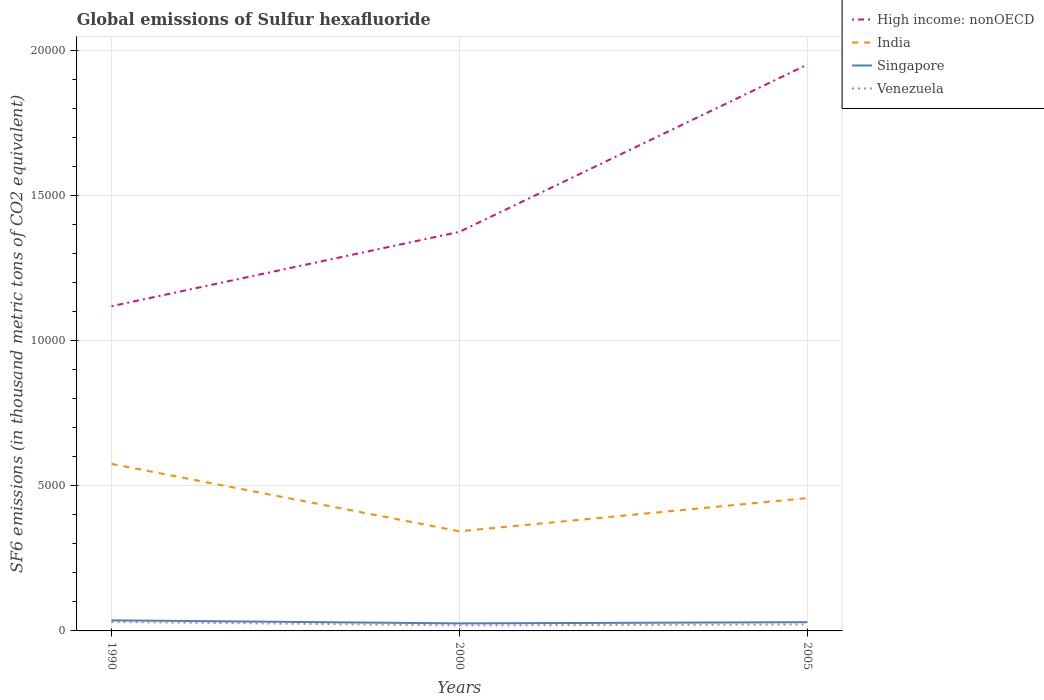How many different coloured lines are there?
Make the answer very short. 4. Does the line corresponding to Venezuela intersect with the line corresponding to High income: nonOECD?
Ensure brevity in your answer.  No. Is the number of lines equal to the number of legend labels?
Offer a very short reply. Yes. Across all years, what is the maximum global emissions of Sulfur hexafluoride in High income: nonOECD?
Keep it short and to the point. 1.12e+04. What is the total global emissions of Sulfur hexafluoride in Singapore in the graph?
Your answer should be very brief. -41.4. What is the difference between the highest and the second highest global emissions of Sulfur hexafluoride in Venezuela?
Offer a terse response. 118.4. How many lines are there?
Keep it short and to the point. 4. How many years are there in the graph?
Your answer should be compact. 3. What is the difference between two consecutive major ticks on the Y-axis?
Make the answer very short. 5000. Are the values on the major ticks of Y-axis written in scientific E-notation?
Ensure brevity in your answer.  No. Does the graph contain grids?
Your answer should be very brief. Yes. How many legend labels are there?
Offer a very short reply. 4. What is the title of the graph?
Keep it short and to the point. Global emissions of Sulfur hexafluoride. Does "Least developed countries" appear as one of the legend labels in the graph?
Your answer should be very brief. No. What is the label or title of the X-axis?
Your response must be concise. Years. What is the label or title of the Y-axis?
Keep it short and to the point. SF6 emissions (in thousand metric tons of CO2 equivalent). What is the SF6 emissions (in thousand metric tons of CO2 equivalent) of High income: nonOECD in 1990?
Ensure brevity in your answer.  1.12e+04. What is the SF6 emissions (in thousand metric tons of CO2 equivalent) of India in 1990?
Ensure brevity in your answer.  5757.5. What is the SF6 emissions (in thousand metric tons of CO2 equivalent) of Singapore in 1990?
Provide a short and direct response. 364.7. What is the SF6 emissions (in thousand metric tons of CO2 equivalent) of Venezuela in 1990?
Offer a terse response. 309.8. What is the SF6 emissions (in thousand metric tons of CO2 equivalent) of High income: nonOECD in 2000?
Make the answer very short. 1.38e+04. What is the SF6 emissions (in thousand metric tons of CO2 equivalent) of India in 2000?
Ensure brevity in your answer.  3434.7. What is the SF6 emissions (in thousand metric tons of CO2 equivalent) of Singapore in 2000?
Keep it short and to the point. 259.8. What is the SF6 emissions (in thousand metric tons of CO2 equivalent) in Venezuela in 2000?
Give a very brief answer. 191.4. What is the SF6 emissions (in thousand metric tons of CO2 equivalent) of High income: nonOECD in 2005?
Ensure brevity in your answer.  1.95e+04. What is the SF6 emissions (in thousand metric tons of CO2 equivalent) of India in 2005?
Your response must be concise. 4578.7. What is the SF6 emissions (in thousand metric tons of CO2 equivalent) in Singapore in 2005?
Your answer should be very brief. 301.2. What is the SF6 emissions (in thousand metric tons of CO2 equivalent) in Venezuela in 2005?
Offer a terse response. 225.1. Across all years, what is the maximum SF6 emissions (in thousand metric tons of CO2 equivalent) in High income: nonOECD?
Keep it short and to the point. 1.95e+04. Across all years, what is the maximum SF6 emissions (in thousand metric tons of CO2 equivalent) in India?
Offer a very short reply. 5757.5. Across all years, what is the maximum SF6 emissions (in thousand metric tons of CO2 equivalent) in Singapore?
Ensure brevity in your answer.  364.7. Across all years, what is the maximum SF6 emissions (in thousand metric tons of CO2 equivalent) in Venezuela?
Provide a succinct answer. 309.8. Across all years, what is the minimum SF6 emissions (in thousand metric tons of CO2 equivalent) in High income: nonOECD?
Offer a very short reply. 1.12e+04. Across all years, what is the minimum SF6 emissions (in thousand metric tons of CO2 equivalent) in India?
Keep it short and to the point. 3434.7. Across all years, what is the minimum SF6 emissions (in thousand metric tons of CO2 equivalent) in Singapore?
Provide a short and direct response. 259.8. Across all years, what is the minimum SF6 emissions (in thousand metric tons of CO2 equivalent) in Venezuela?
Your response must be concise. 191.4. What is the total SF6 emissions (in thousand metric tons of CO2 equivalent) in High income: nonOECD in the graph?
Ensure brevity in your answer.  4.45e+04. What is the total SF6 emissions (in thousand metric tons of CO2 equivalent) in India in the graph?
Your response must be concise. 1.38e+04. What is the total SF6 emissions (in thousand metric tons of CO2 equivalent) of Singapore in the graph?
Provide a short and direct response. 925.7. What is the total SF6 emissions (in thousand metric tons of CO2 equivalent) of Venezuela in the graph?
Make the answer very short. 726.3. What is the difference between the SF6 emissions (in thousand metric tons of CO2 equivalent) of High income: nonOECD in 1990 and that in 2000?
Offer a terse response. -2562.3. What is the difference between the SF6 emissions (in thousand metric tons of CO2 equivalent) in India in 1990 and that in 2000?
Make the answer very short. 2322.8. What is the difference between the SF6 emissions (in thousand metric tons of CO2 equivalent) of Singapore in 1990 and that in 2000?
Your answer should be compact. 104.9. What is the difference between the SF6 emissions (in thousand metric tons of CO2 equivalent) of Venezuela in 1990 and that in 2000?
Provide a succinct answer. 118.4. What is the difference between the SF6 emissions (in thousand metric tons of CO2 equivalent) of High income: nonOECD in 1990 and that in 2005?
Provide a short and direct response. -8325.44. What is the difference between the SF6 emissions (in thousand metric tons of CO2 equivalent) of India in 1990 and that in 2005?
Your answer should be compact. 1178.8. What is the difference between the SF6 emissions (in thousand metric tons of CO2 equivalent) in Singapore in 1990 and that in 2005?
Ensure brevity in your answer.  63.5. What is the difference between the SF6 emissions (in thousand metric tons of CO2 equivalent) of Venezuela in 1990 and that in 2005?
Provide a short and direct response. 84.7. What is the difference between the SF6 emissions (in thousand metric tons of CO2 equivalent) in High income: nonOECD in 2000 and that in 2005?
Keep it short and to the point. -5763.14. What is the difference between the SF6 emissions (in thousand metric tons of CO2 equivalent) of India in 2000 and that in 2005?
Offer a very short reply. -1144. What is the difference between the SF6 emissions (in thousand metric tons of CO2 equivalent) of Singapore in 2000 and that in 2005?
Make the answer very short. -41.4. What is the difference between the SF6 emissions (in thousand metric tons of CO2 equivalent) in Venezuela in 2000 and that in 2005?
Your response must be concise. -33.7. What is the difference between the SF6 emissions (in thousand metric tons of CO2 equivalent) of High income: nonOECD in 1990 and the SF6 emissions (in thousand metric tons of CO2 equivalent) of India in 2000?
Provide a succinct answer. 7757.5. What is the difference between the SF6 emissions (in thousand metric tons of CO2 equivalent) of High income: nonOECD in 1990 and the SF6 emissions (in thousand metric tons of CO2 equivalent) of Singapore in 2000?
Provide a succinct answer. 1.09e+04. What is the difference between the SF6 emissions (in thousand metric tons of CO2 equivalent) in High income: nonOECD in 1990 and the SF6 emissions (in thousand metric tons of CO2 equivalent) in Venezuela in 2000?
Offer a very short reply. 1.10e+04. What is the difference between the SF6 emissions (in thousand metric tons of CO2 equivalent) of India in 1990 and the SF6 emissions (in thousand metric tons of CO2 equivalent) of Singapore in 2000?
Your answer should be very brief. 5497.7. What is the difference between the SF6 emissions (in thousand metric tons of CO2 equivalent) in India in 1990 and the SF6 emissions (in thousand metric tons of CO2 equivalent) in Venezuela in 2000?
Provide a short and direct response. 5566.1. What is the difference between the SF6 emissions (in thousand metric tons of CO2 equivalent) in Singapore in 1990 and the SF6 emissions (in thousand metric tons of CO2 equivalent) in Venezuela in 2000?
Give a very brief answer. 173.3. What is the difference between the SF6 emissions (in thousand metric tons of CO2 equivalent) in High income: nonOECD in 1990 and the SF6 emissions (in thousand metric tons of CO2 equivalent) in India in 2005?
Your response must be concise. 6613.5. What is the difference between the SF6 emissions (in thousand metric tons of CO2 equivalent) in High income: nonOECD in 1990 and the SF6 emissions (in thousand metric tons of CO2 equivalent) in Singapore in 2005?
Keep it short and to the point. 1.09e+04. What is the difference between the SF6 emissions (in thousand metric tons of CO2 equivalent) of High income: nonOECD in 1990 and the SF6 emissions (in thousand metric tons of CO2 equivalent) of Venezuela in 2005?
Provide a short and direct response. 1.10e+04. What is the difference between the SF6 emissions (in thousand metric tons of CO2 equivalent) in India in 1990 and the SF6 emissions (in thousand metric tons of CO2 equivalent) in Singapore in 2005?
Offer a very short reply. 5456.3. What is the difference between the SF6 emissions (in thousand metric tons of CO2 equivalent) of India in 1990 and the SF6 emissions (in thousand metric tons of CO2 equivalent) of Venezuela in 2005?
Offer a very short reply. 5532.4. What is the difference between the SF6 emissions (in thousand metric tons of CO2 equivalent) in Singapore in 1990 and the SF6 emissions (in thousand metric tons of CO2 equivalent) in Venezuela in 2005?
Offer a terse response. 139.6. What is the difference between the SF6 emissions (in thousand metric tons of CO2 equivalent) in High income: nonOECD in 2000 and the SF6 emissions (in thousand metric tons of CO2 equivalent) in India in 2005?
Your response must be concise. 9175.8. What is the difference between the SF6 emissions (in thousand metric tons of CO2 equivalent) of High income: nonOECD in 2000 and the SF6 emissions (in thousand metric tons of CO2 equivalent) of Singapore in 2005?
Give a very brief answer. 1.35e+04. What is the difference between the SF6 emissions (in thousand metric tons of CO2 equivalent) of High income: nonOECD in 2000 and the SF6 emissions (in thousand metric tons of CO2 equivalent) of Venezuela in 2005?
Ensure brevity in your answer.  1.35e+04. What is the difference between the SF6 emissions (in thousand metric tons of CO2 equivalent) in India in 2000 and the SF6 emissions (in thousand metric tons of CO2 equivalent) in Singapore in 2005?
Make the answer very short. 3133.5. What is the difference between the SF6 emissions (in thousand metric tons of CO2 equivalent) of India in 2000 and the SF6 emissions (in thousand metric tons of CO2 equivalent) of Venezuela in 2005?
Your response must be concise. 3209.6. What is the difference between the SF6 emissions (in thousand metric tons of CO2 equivalent) in Singapore in 2000 and the SF6 emissions (in thousand metric tons of CO2 equivalent) in Venezuela in 2005?
Your answer should be compact. 34.7. What is the average SF6 emissions (in thousand metric tons of CO2 equivalent) of High income: nonOECD per year?
Make the answer very short. 1.48e+04. What is the average SF6 emissions (in thousand metric tons of CO2 equivalent) in India per year?
Offer a terse response. 4590.3. What is the average SF6 emissions (in thousand metric tons of CO2 equivalent) of Singapore per year?
Give a very brief answer. 308.57. What is the average SF6 emissions (in thousand metric tons of CO2 equivalent) in Venezuela per year?
Ensure brevity in your answer.  242.1. In the year 1990, what is the difference between the SF6 emissions (in thousand metric tons of CO2 equivalent) of High income: nonOECD and SF6 emissions (in thousand metric tons of CO2 equivalent) of India?
Ensure brevity in your answer.  5434.7. In the year 1990, what is the difference between the SF6 emissions (in thousand metric tons of CO2 equivalent) of High income: nonOECD and SF6 emissions (in thousand metric tons of CO2 equivalent) of Singapore?
Give a very brief answer. 1.08e+04. In the year 1990, what is the difference between the SF6 emissions (in thousand metric tons of CO2 equivalent) of High income: nonOECD and SF6 emissions (in thousand metric tons of CO2 equivalent) of Venezuela?
Keep it short and to the point. 1.09e+04. In the year 1990, what is the difference between the SF6 emissions (in thousand metric tons of CO2 equivalent) in India and SF6 emissions (in thousand metric tons of CO2 equivalent) in Singapore?
Your answer should be compact. 5392.8. In the year 1990, what is the difference between the SF6 emissions (in thousand metric tons of CO2 equivalent) in India and SF6 emissions (in thousand metric tons of CO2 equivalent) in Venezuela?
Give a very brief answer. 5447.7. In the year 1990, what is the difference between the SF6 emissions (in thousand metric tons of CO2 equivalent) in Singapore and SF6 emissions (in thousand metric tons of CO2 equivalent) in Venezuela?
Provide a succinct answer. 54.9. In the year 2000, what is the difference between the SF6 emissions (in thousand metric tons of CO2 equivalent) in High income: nonOECD and SF6 emissions (in thousand metric tons of CO2 equivalent) in India?
Your answer should be compact. 1.03e+04. In the year 2000, what is the difference between the SF6 emissions (in thousand metric tons of CO2 equivalent) of High income: nonOECD and SF6 emissions (in thousand metric tons of CO2 equivalent) of Singapore?
Provide a short and direct response. 1.35e+04. In the year 2000, what is the difference between the SF6 emissions (in thousand metric tons of CO2 equivalent) of High income: nonOECD and SF6 emissions (in thousand metric tons of CO2 equivalent) of Venezuela?
Ensure brevity in your answer.  1.36e+04. In the year 2000, what is the difference between the SF6 emissions (in thousand metric tons of CO2 equivalent) in India and SF6 emissions (in thousand metric tons of CO2 equivalent) in Singapore?
Keep it short and to the point. 3174.9. In the year 2000, what is the difference between the SF6 emissions (in thousand metric tons of CO2 equivalent) in India and SF6 emissions (in thousand metric tons of CO2 equivalent) in Venezuela?
Keep it short and to the point. 3243.3. In the year 2000, what is the difference between the SF6 emissions (in thousand metric tons of CO2 equivalent) of Singapore and SF6 emissions (in thousand metric tons of CO2 equivalent) of Venezuela?
Your response must be concise. 68.4. In the year 2005, what is the difference between the SF6 emissions (in thousand metric tons of CO2 equivalent) of High income: nonOECD and SF6 emissions (in thousand metric tons of CO2 equivalent) of India?
Your answer should be compact. 1.49e+04. In the year 2005, what is the difference between the SF6 emissions (in thousand metric tons of CO2 equivalent) in High income: nonOECD and SF6 emissions (in thousand metric tons of CO2 equivalent) in Singapore?
Give a very brief answer. 1.92e+04. In the year 2005, what is the difference between the SF6 emissions (in thousand metric tons of CO2 equivalent) in High income: nonOECD and SF6 emissions (in thousand metric tons of CO2 equivalent) in Venezuela?
Your answer should be very brief. 1.93e+04. In the year 2005, what is the difference between the SF6 emissions (in thousand metric tons of CO2 equivalent) in India and SF6 emissions (in thousand metric tons of CO2 equivalent) in Singapore?
Provide a short and direct response. 4277.5. In the year 2005, what is the difference between the SF6 emissions (in thousand metric tons of CO2 equivalent) in India and SF6 emissions (in thousand metric tons of CO2 equivalent) in Venezuela?
Provide a succinct answer. 4353.6. In the year 2005, what is the difference between the SF6 emissions (in thousand metric tons of CO2 equivalent) in Singapore and SF6 emissions (in thousand metric tons of CO2 equivalent) in Venezuela?
Provide a succinct answer. 76.1. What is the ratio of the SF6 emissions (in thousand metric tons of CO2 equivalent) in High income: nonOECD in 1990 to that in 2000?
Offer a terse response. 0.81. What is the ratio of the SF6 emissions (in thousand metric tons of CO2 equivalent) of India in 1990 to that in 2000?
Ensure brevity in your answer.  1.68. What is the ratio of the SF6 emissions (in thousand metric tons of CO2 equivalent) of Singapore in 1990 to that in 2000?
Keep it short and to the point. 1.4. What is the ratio of the SF6 emissions (in thousand metric tons of CO2 equivalent) in Venezuela in 1990 to that in 2000?
Ensure brevity in your answer.  1.62. What is the ratio of the SF6 emissions (in thousand metric tons of CO2 equivalent) of High income: nonOECD in 1990 to that in 2005?
Your answer should be compact. 0.57. What is the ratio of the SF6 emissions (in thousand metric tons of CO2 equivalent) in India in 1990 to that in 2005?
Offer a terse response. 1.26. What is the ratio of the SF6 emissions (in thousand metric tons of CO2 equivalent) of Singapore in 1990 to that in 2005?
Your answer should be very brief. 1.21. What is the ratio of the SF6 emissions (in thousand metric tons of CO2 equivalent) of Venezuela in 1990 to that in 2005?
Ensure brevity in your answer.  1.38. What is the ratio of the SF6 emissions (in thousand metric tons of CO2 equivalent) of High income: nonOECD in 2000 to that in 2005?
Keep it short and to the point. 0.7. What is the ratio of the SF6 emissions (in thousand metric tons of CO2 equivalent) of India in 2000 to that in 2005?
Keep it short and to the point. 0.75. What is the ratio of the SF6 emissions (in thousand metric tons of CO2 equivalent) in Singapore in 2000 to that in 2005?
Offer a terse response. 0.86. What is the ratio of the SF6 emissions (in thousand metric tons of CO2 equivalent) of Venezuela in 2000 to that in 2005?
Keep it short and to the point. 0.85. What is the difference between the highest and the second highest SF6 emissions (in thousand metric tons of CO2 equivalent) of High income: nonOECD?
Your answer should be very brief. 5763.14. What is the difference between the highest and the second highest SF6 emissions (in thousand metric tons of CO2 equivalent) in India?
Give a very brief answer. 1178.8. What is the difference between the highest and the second highest SF6 emissions (in thousand metric tons of CO2 equivalent) of Singapore?
Your answer should be compact. 63.5. What is the difference between the highest and the second highest SF6 emissions (in thousand metric tons of CO2 equivalent) in Venezuela?
Offer a very short reply. 84.7. What is the difference between the highest and the lowest SF6 emissions (in thousand metric tons of CO2 equivalent) in High income: nonOECD?
Your response must be concise. 8325.44. What is the difference between the highest and the lowest SF6 emissions (in thousand metric tons of CO2 equivalent) of India?
Your response must be concise. 2322.8. What is the difference between the highest and the lowest SF6 emissions (in thousand metric tons of CO2 equivalent) in Singapore?
Provide a short and direct response. 104.9. What is the difference between the highest and the lowest SF6 emissions (in thousand metric tons of CO2 equivalent) of Venezuela?
Offer a terse response. 118.4. 